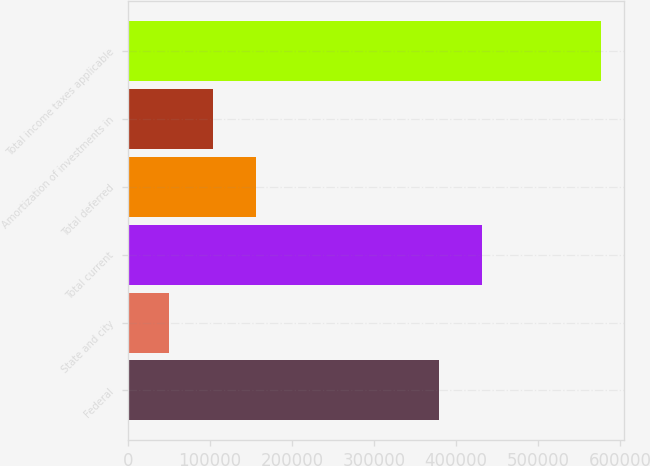Convert chart to OTSL. <chart><loc_0><loc_0><loc_500><loc_500><bar_chart><fcel>Federal<fcel>State and city<fcel>Total current<fcel>Total deferred<fcel>Amortization of investments in<fcel>Total income taxes applicable<nl><fcel>378978<fcel>50790<fcel>431499<fcel>155832<fcel>103311<fcel>575999<nl></chart> 